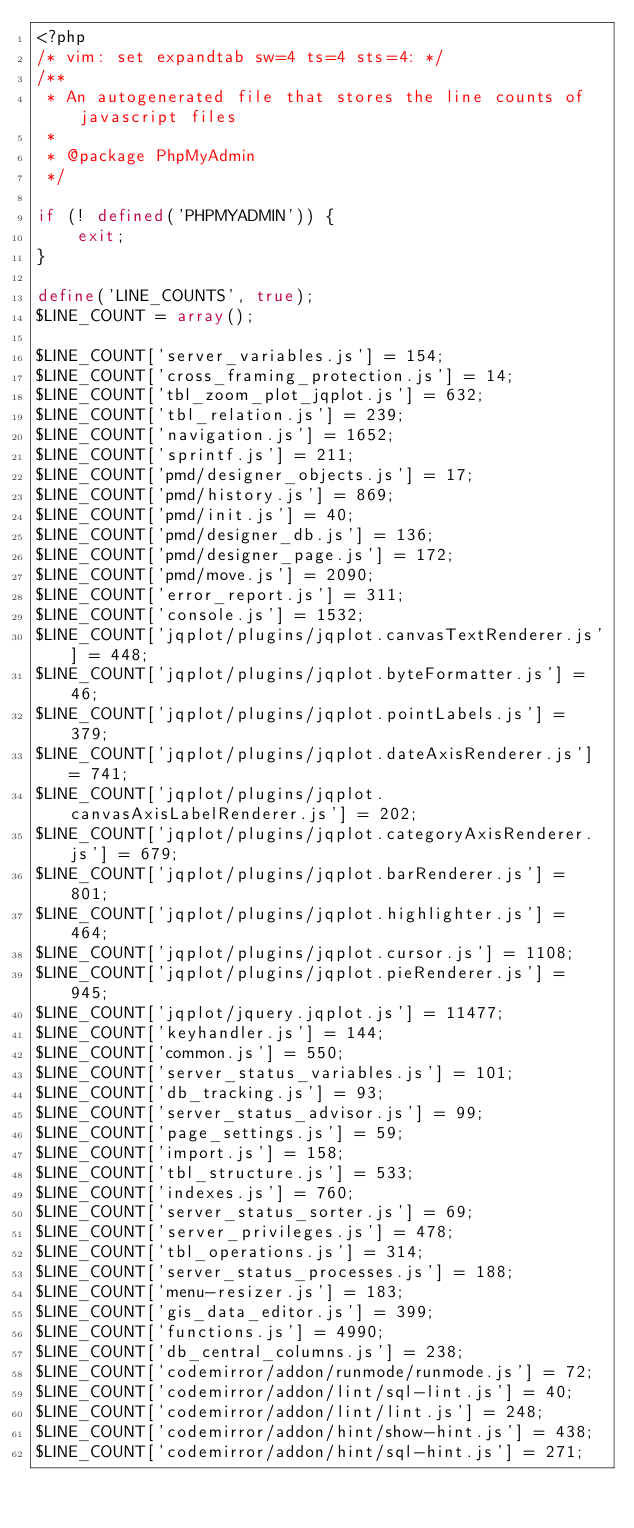<code> <loc_0><loc_0><loc_500><loc_500><_PHP_><?php
/* vim: set expandtab sw=4 ts=4 sts=4: */
/**
 * An autogenerated file that stores the line counts of javascript files
 *
 * @package PhpMyAdmin
 */

if (! defined('PHPMYADMIN')) {
    exit;
}

define('LINE_COUNTS', true);
$LINE_COUNT = array();

$LINE_COUNT['server_variables.js'] = 154;
$LINE_COUNT['cross_framing_protection.js'] = 14;
$LINE_COUNT['tbl_zoom_plot_jqplot.js'] = 632;
$LINE_COUNT['tbl_relation.js'] = 239;
$LINE_COUNT['navigation.js'] = 1652;
$LINE_COUNT['sprintf.js'] = 211;
$LINE_COUNT['pmd/designer_objects.js'] = 17;
$LINE_COUNT['pmd/history.js'] = 869;
$LINE_COUNT['pmd/init.js'] = 40;
$LINE_COUNT['pmd/designer_db.js'] = 136;
$LINE_COUNT['pmd/designer_page.js'] = 172;
$LINE_COUNT['pmd/move.js'] = 2090;
$LINE_COUNT['error_report.js'] = 311;
$LINE_COUNT['console.js'] = 1532;
$LINE_COUNT['jqplot/plugins/jqplot.canvasTextRenderer.js'] = 448;
$LINE_COUNT['jqplot/plugins/jqplot.byteFormatter.js'] = 46;
$LINE_COUNT['jqplot/plugins/jqplot.pointLabels.js'] = 379;
$LINE_COUNT['jqplot/plugins/jqplot.dateAxisRenderer.js'] = 741;
$LINE_COUNT['jqplot/plugins/jqplot.canvasAxisLabelRenderer.js'] = 202;
$LINE_COUNT['jqplot/plugins/jqplot.categoryAxisRenderer.js'] = 679;
$LINE_COUNT['jqplot/plugins/jqplot.barRenderer.js'] = 801;
$LINE_COUNT['jqplot/plugins/jqplot.highlighter.js'] = 464;
$LINE_COUNT['jqplot/plugins/jqplot.cursor.js'] = 1108;
$LINE_COUNT['jqplot/plugins/jqplot.pieRenderer.js'] = 945;
$LINE_COUNT['jqplot/jquery.jqplot.js'] = 11477;
$LINE_COUNT['keyhandler.js'] = 144;
$LINE_COUNT['common.js'] = 550;
$LINE_COUNT['server_status_variables.js'] = 101;
$LINE_COUNT['db_tracking.js'] = 93;
$LINE_COUNT['server_status_advisor.js'] = 99;
$LINE_COUNT['page_settings.js'] = 59;
$LINE_COUNT['import.js'] = 158;
$LINE_COUNT['tbl_structure.js'] = 533;
$LINE_COUNT['indexes.js'] = 760;
$LINE_COUNT['server_status_sorter.js'] = 69;
$LINE_COUNT['server_privileges.js'] = 478;
$LINE_COUNT['tbl_operations.js'] = 314;
$LINE_COUNT['server_status_processes.js'] = 188;
$LINE_COUNT['menu-resizer.js'] = 183;
$LINE_COUNT['gis_data_editor.js'] = 399;
$LINE_COUNT['functions.js'] = 4990;
$LINE_COUNT['db_central_columns.js'] = 238;
$LINE_COUNT['codemirror/addon/runmode/runmode.js'] = 72;
$LINE_COUNT['codemirror/addon/lint/sql-lint.js'] = 40;
$LINE_COUNT['codemirror/addon/lint/lint.js'] = 248;
$LINE_COUNT['codemirror/addon/hint/show-hint.js'] = 438;
$LINE_COUNT['codemirror/addon/hint/sql-hint.js'] = 271;</code> 